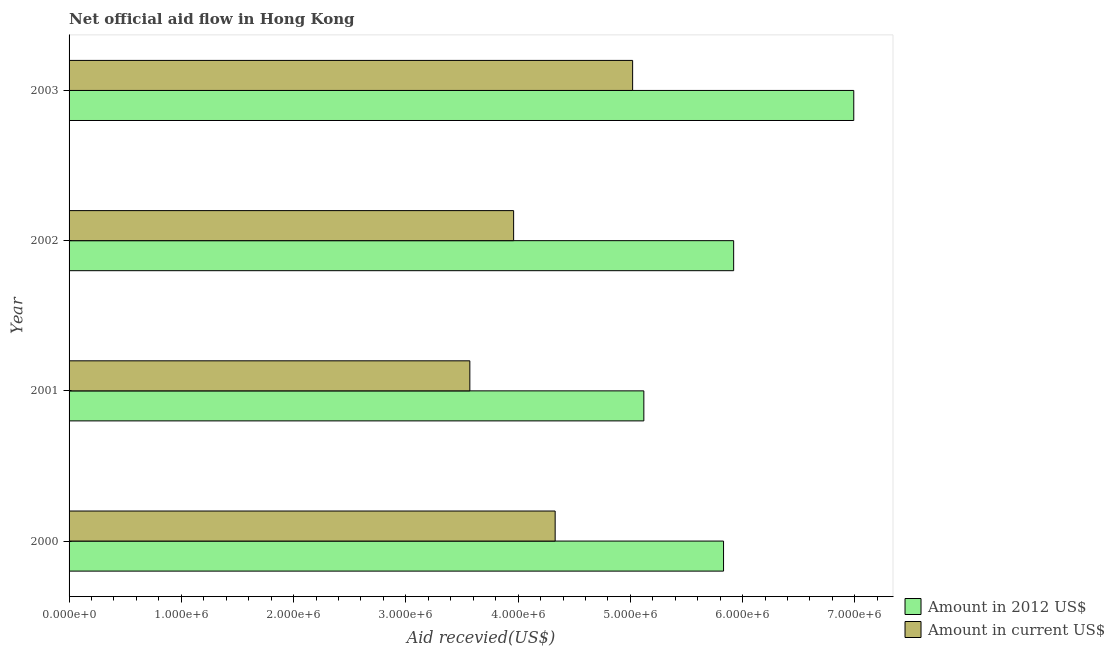How many different coloured bars are there?
Provide a succinct answer. 2. Are the number of bars per tick equal to the number of legend labels?
Give a very brief answer. Yes. Are the number of bars on each tick of the Y-axis equal?
Your answer should be very brief. Yes. How many bars are there on the 1st tick from the bottom?
Ensure brevity in your answer.  2. What is the label of the 4th group of bars from the top?
Offer a terse response. 2000. What is the amount of aid received(expressed in us$) in 2001?
Your answer should be compact. 3.57e+06. Across all years, what is the maximum amount of aid received(expressed in 2012 us$)?
Your response must be concise. 6.99e+06. Across all years, what is the minimum amount of aid received(expressed in 2012 us$)?
Make the answer very short. 5.12e+06. In which year was the amount of aid received(expressed in us$) minimum?
Provide a short and direct response. 2001. What is the total amount of aid received(expressed in us$) in the graph?
Provide a succinct answer. 1.69e+07. What is the difference between the amount of aid received(expressed in 2012 us$) in 2000 and that in 2003?
Offer a very short reply. -1.16e+06. What is the difference between the amount of aid received(expressed in 2012 us$) in 2001 and the amount of aid received(expressed in us$) in 2002?
Keep it short and to the point. 1.16e+06. What is the average amount of aid received(expressed in 2012 us$) per year?
Keep it short and to the point. 5.96e+06. In the year 2002, what is the difference between the amount of aid received(expressed in us$) and amount of aid received(expressed in 2012 us$)?
Your response must be concise. -1.96e+06. What is the ratio of the amount of aid received(expressed in us$) in 2001 to that in 2003?
Make the answer very short. 0.71. Is the amount of aid received(expressed in us$) in 2000 less than that in 2001?
Keep it short and to the point. No. What is the difference between the highest and the second highest amount of aid received(expressed in 2012 us$)?
Ensure brevity in your answer.  1.07e+06. What is the difference between the highest and the lowest amount of aid received(expressed in 2012 us$)?
Keep it short and to the point. 1.87e+06. Is the sum of the amount of aid received(expressed in us$) in 2000 and 2003 greater than the maximum amount of aid received(expressed in 2012 us$) across all years?
Provide a succinct answer. Yes. What does the 2nd bar from the top in 2000 represents?
Give a very brief answer. Amount in 2012 US$. What does the 2nd bar from the bottom in 2002 represents?
Keep it short and to the point. Amount in current US$. How many years are there in the graph?
Ensure brevity in your answer.  4. What is the difference between two consecutive major ticks on the X-axis?
Give a very brief answer. 1.00e+06. Are the values on the major ticks of X-axis written in scientific E-notation?
Ensure brevity in your answer.  Yes. Does the graph contain any zero values?
Offer a terse response. No. How many legend labels are there?
Your answer should be very brief. 2. How are the legend labels stacked?
Offer a very short reply. Vertical. What is the title of the graph?
Give a very brief answer. Net official aid flow in Hong Kong. What is the label or title of the X-axis?
Offer a very short reply. Aid recevied(US$). What is the Aid recevied(US$) in Amount in 2012 US$ in 2000?
Your answer should be very brief. 5.83e+06. What is the Aid recevied(US$) in Amount in current US$ in 2000?
Provide a short and direct response. 4.33e+06. What is the Aid recevied(US$) in Amount in 2012 US$ in 2001?
Ensure brevity in your answer.  5.12e+06. What is the Aid recevied(US$) of Amount in current US$ in 2001?
Make the answer very short. 3.57e+06. What is the Aid recevied(US$) in Amount in 2012 US$ in 2002?
Give a very brief answer. 5.92e+06. What is the Aid recevied(US$) in Amount in current US$ in 2002?
Keep it short and to the point. 3.96e+06. What is the Aid recevied(US$) of Amount in 2012 US$ in 2003?
Your response must be concise. 6.99e+06. What is the Aid recevied(US$) of Amount in current US$ in 2003?
Ensure brevity in your answer.  5.02e+06. Across all years, what is the maximum Aid recevied(US$) in Amount in 2012 US$?
Offer a terse response. 6.99e+06. Across all years, what is the maximum Aid recevied(US$) in Amount in current US$?
Your response must be concise. 5.02e+06. Across all years, what is the minimum Aid recevied(US$) in Amount in 2012 US$?
Offer a very short reply. 5.12e+06. Across all years, what is the minimum Aid recevied(US$) of Amount in current US$?
Keep it short and to the point. 3.57e+06. What is the total Aid recevied(US$) in Amount in 2012 US$ in the graph?
Ensure brevity in your answer.  2.39e+07. What is the total Aid recevied(US$) of Amount in current US$ in the graph?
Keep it short and to the point. 1.69e+07. What is the difference between the Aid recevied(US$) in Amount in 2012 US$ in 2000 and that in 2001?
Your answer should be very brief. 7.10e+05. What is the difference between the Aid recevied(US$) in Amount in current US$ in 2000 and that in 2001?
Keep it short and to the point. 7.60e+05. What is the difference between the Aid recevied(US$) of Amount in 2012 US$ in 2000 and that in 2003?
Ensure brevity in your answer.  -1.16e+06. What is the difference between the Aid recevied(US$) in Amount in current US$ in 2000 and that in 2003?
Offer a very short reply. -6.90e+05. What is the difference between the Aid recevied(US$) in Amount in 2012 US$ in 2001 and that in 2002?
Provide a succinct answer. -8.00e+05. What is the difference between the Aid recevied(US$) in Amount in current US$ in 2001 and that in 2002?
Offer a very short reply. -3.90e+05. What is the difference between the Aid recevied(US$) of Amount in 2012 US$ in 2001 and that in 2003?
Make the answer very short. -1.87e+06. What is the difference between the Aid recevied(US$) of Amount in current US$ in 2001 and that in 2003?
Your answer should be compact. -1.45e+06. What is the difference between the Aid recevied(US$) of Amount in 2012 US$ in 2002 and that in 2003?
Keep it short and to the point. -1.07e+06. What is the difference between the Aid recevied(US$) of Amount in current US$ in 2002 and that in 2003?
Your response must be concise. -1.06e+06. What is the difference between the Aid recevied(US$) of Amount in 2012 US$ in 2000 and the Aid recevied(US$) of Amount in current US$ in 2001?
Ensure brevity in your answer.  2.26e+06. What is the difference between the Aid recevied(US$) in Amount in 2012 US$ in 2000 and the Aid recevied(US$) in Amount in current US$ in 2002?
Make the answer very short. 1.87e+06. What is the difference between the Aid recevied(US$) in Amount in 2012 US$ in 2000 and the Aid recevied(US$) in Amount in current US$ in 2003?
Your answer should be compact. 8.10e+05. What is the difference between the Aid recevied(US$) in Amount in 2012 US$ in 2001 and the Aid recevied(US$) in Amount in current US$ in 2002?
Provide a short and direct response. 1.16e+06. What is the difference between the Aid recevied(US$) of Amount in 2012 US$ in 2001 and the Aid recevied(US$) of Amount in current US$ in 2003?
Your answer should be very brief. 1.00e+05. What is the difference between the Aid recevied(US$) in Amount in 2012 US$ in 2002 and the Aid recevied(US$) in Amount in current US$ in 2003?
Ensure brevity in your answer.  9.00e+05. What is the average Aid recevied(US$) of Amount in 2012 US$ per year?
Your answer should be compact. 5.96e+06. What is the average Aid recevied(US$) of Amount in current US$ per year?
Your response must be concise. 4.22e+06. In the year 2000, what is the difference between the Aid recevied(US$) of Amount in 2012 US$ and Aid recevied(US$) of Amount in current US$?
Your answer should be very brief. 1.50e+06. In the year 2001, what is the difference between the Aid recevied(US$) of Amount in 2012 US$ and Aid recevied(US$) of Amount in current US$?
Provide a succinct answer. 1.55e+06. In the year 2002, what is the difference between the Aid recevied(US$) of Amount in 2012 US$ and Aid recevied(US$) of Amount in current US$?
Your answer should be very brief. 1.96e+06. In the year 2003, what is the difference between the Aid recevied(US$) of Amount in 2012 US$ and Aid recevied(US$) of Amount in current US$?
Make the answer very short. 1.97e+06. What is the ratio of the Aid recevied(US$) of Amount in 2012 US$ in 2000 to that in 2001?
Your answer should be compact. 1.14. What is the ratio of the Aid recevied(US$) of Amount in current US$ in 2000 to that in 2001?
Give a very brief answer. 1.21. What is the ratio of the Aid recevied(US$) of Amount in current US$ in 2000 to that in 2002?
Keep it short and to the point. 1.09. What is the ratio of the Aid recevied(US$) of Amount in 2012 US$ in 2000 to that in 2003?
Offer a terse response. 0.83. What is the ratio of the Aid recevied(US$) in Amount in current US$ in 2000 to that in 2003?
Offer a terse response. 0.86. What is the ratio of the Aid recevied(US$) in Amount in 2012 US$ in 2001 to that in 2002?
Offer a very short reply. 0.86. What is the ratio of the Aid recevied(US$) in Amount in current US$ in 2001 to that in 2002?
Offer a terse response. 0.9. What is the ratio of the Aid recevied(US$) of Amount in 2012 US$ in 2001 to that in 2003?
Ensure brevity in your answer.  0.73. What is the ratio of the Aid recevied(US$) of Amount in current US$ in 2001 to that in 2003?
Ensure brevity in your answer.  0.71. What is the ratio of the Aid recevied(US$) in Amount in 2012 US$ in 2002 to that in 2003?
Your response must be concise. 0.85. What is the ratio of the Aid recevied(US$) in Amount in current US$ in 2002 to that in 2003?
Your response must be concise. 0.79. What is the difference between the highest and the second highest Aid recevied(US$) in Amount in 2012 US$?
Your answer should be very brief. 1.07e+06. What is the difference between the highest and the second highest Aid recevied(US$) in Amount in current US$?
Provide a succinct answer. 6.90e+05. What is the difference between the highest and the lowest Aid recevied(US$) of Amount in 2012 US$?
Provide a succinct answer. 1.87e+06. What is the difference between the highest and the lowest Aid recevied(US$) in Amount in current US$?
Make the answer very short. 1.45e+06. 